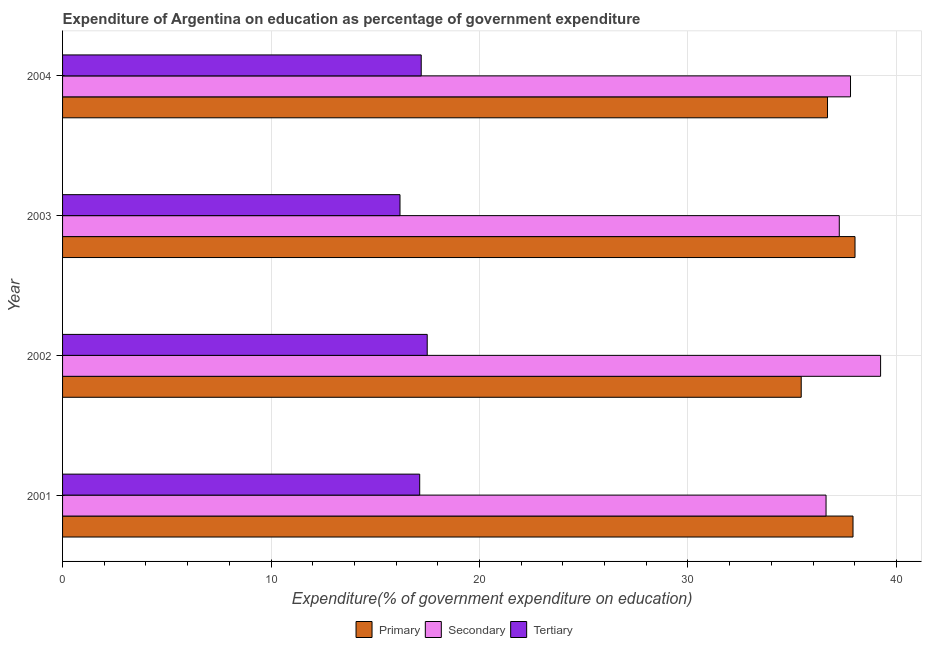How many bars are there on the 4th tick from the top?
Provide a short and direct response. 3. In how many cases, is the number of bars for a given year not equal to the number of legend labels?
Your answer should be compact. 0. What is the expenditure on primary education in 2003?
Make the answer very short. 38.01. Across all years, what is the maximum expenditure on secondary education?
Provide a succinct answer. 39.24. Across all years, what is the minimum expenditure on secondary education?
Make the answer very short. 36.63. In which year was the expenditure on tertiary education maximum?
Your answer should be compact. 2002. What is the total expenditure on secondary education in the graph?
Your answer should be very brief. 150.93. What is the difference between the expenditure on tertiary education in 2002 and that in 2004?
Provide a succinct answer. 0.29. What is the difference between the expenditure on tertiary education in 2001 and the expenditure on primary education in 2004?
Give a very brief answer. -19.56. What is the average expenditure on tertiary education per year?
Your answer should be very brief. 17. In the year 2003, what is the difference between the expenditure on tertiary education and expenditure on secondary education?
Make the answer very short. -21.07. What is the ratio of the expenditure on primary education in 2001 to that in 2004?
Provide a succinct answer. 1.03. What is the difference between the highest and the second highest expenditure on secondary education?
Offer a very short reply. 1.44. What is the difference between the highest and the lowest expenditure on tertiary education?
Offer a very short reply. 1.31. In how many years, is the expenditure on primary education greater than the average expenditure on primary education taken over all years?
Make the answer very short. 2. What does the 2nd bar from the top in 2004 represents?
Your response must be concise. Secondary. What does the 2nd bar from the bottom in 2001 represents?
Give a very brief answer. Secondary. How many years are there in the graph?
Offer a terse response. 4. Are the values on the major ticks of X-axis written in scientific E-notation?
Provide a short and direct response. No. Does the graph contain grids?
Keep it short and to the point. Yes. Where does the legend appear in the graph?
Provide a short and direct response. Bottom center. How many legend labels are there?
Keep it short and to the point. 3. How are the legend labels stacked?
Provide a short and direct response. Horizontal. What is the title of the graph?
Your answer should be very brief. Expenditure of Argentina on education as percentage of government expenditure. Does "Primary education" appear as one of the legend labels in the graph?
Provide a succinct answer. No. What is the label or title of the X-axis?
Give a very brief answer. Expenditure(% of government expenditure on education). What is the label or title of the Y-axis?
Provide a succinct answer. Year. What is the Expenditure(% of government expenditure on education) in Primary in 2001?
Offer a very short reply. 37.92. What is the Expenditure(% of government expenditure on education) of Secondary in 2001?
Your answer should be very brief. 36.63. What is the Expenditure(% of government expenditure on education) in Tertiary in 2001?
Offer a terse response. 17.13. What is the Expenditure(% of government expenditure on education) in Primary in 2002?
Your answer should be compact. 35.43. What is the Expenditure(% of government expenditure on education) in Secondary in 2002?
Ensure brevity in your answer.  39.24. What is the Expenditure(% of government expenditure on education) in Tertiary in 2002?
Keep it short and to the point. 17.49. What is the Expenditure(% of government expenditure on education) in Primary in 2003?
Ensure brevity in your answer.  38.01. What is the Expenditure(% of government expenditure on education) of Secondary in 2003?
Give a very brief answer. 37.26. What is the Expenditure(% of government expenditure on education) in Tertiary in 2003?
Provide a succinct answer. 16.19. What is the Expenditure(% of government expenditure on education) of Primary in 2004?
Your answer should be very brief. 36.7. What is the Expenditure(% of government expenditure on education) in Secondary in 2004?
Provide a succinct answer. 37.8. What is the Expenditure(% of government expenditure on education) in Tertiary in 2004?
Make the answer very short. 17.2. Across all years, what is the maximum Expenditure(% of government expenditure on education) of Primary?
Give a very brief answer. 38.01. Across all years, what is the maximum Expenditure(% of government expenditure on education) in Secondary?
Offer a very short reply. 39.24. Across all years, what is the maximum Expenditure(% of government expenditure on education) in Tertiary?
Provide a succinct answer. 17.49. Across all years, what is the minimum Expenditure(% of government expenditure on education) of Primary?
Give a very brief answer. 35.43. Across all years, what is the minimum Expenditure(% of government expenditure on education) of Secondary?
Keep it short and to the point. 36.63. Across all years, what is the minimum Expenditure(% of government expenditure on education) in Tertiary?
Provide a succinct answer. 16.19. What is the total Expenditure(% of government expenditure on education) in Primary in the graph?
Offer a very short reply. 148.06. What is the total Expenditure(% of government expenditure on education) of Secondary in the graph?
Offer a terse response. 150.93. What is the total Expenditure(% of government expenditure on education) of Tertiary in the graph?
Your answer should be compact. 68.02. What is the difference between the Expenditure(% of government expenditure on education) in Primary in 2001 and that in 2002?
Provide a succinct answer. 2.48. What is the difference between the Expenditure(% of government expenditure on education) of Secondary in 2001 and that in 2002?
Your answer should be very brief. -2.62. What is the difference between the Expenditure(% of government expenditure on education) in Tertiary in 2001 and that in 2002?
Make the answer very short. -0.36. What is the difference between the Expenditure(% of government expenditure on education) in Primary in 2001 and that in 2003?
Your answer should be compact. -0.1. What is the difference between the Expenditure(% of government expenditure on education) in Secondary in 2001 and that in 2003?
Give a very brief answer. -0.63. What is the difference between the Expenditure(% of government expenditure on education) in Tertiary in 2001 and that in 2003?
Your answer should be compact. 0.94. What is the difference between the Expenditure(% of government expenditure on education) of Primary in 2001 and that in 2004?
Make the answer very short. 1.22. What is the difference between the Expenditure(% of government expenditure on education) of Secondary in 2001 and that in 2004?
Make the answer very short. -1.17. What is the difference between the Expenditure(% of government expenditure on education) of Tertiary in 2001 and that in 2004?
Provide a succinct answer. -0.07. What is the difference between the Expenditure(% of government expenditure on education) in Primary in 2002 and that in 2003?
Your answer should be very brief. -2.58. What is the difference between the Expenditure(% of government expenditure on education) of Secondary in 2002 and that in 2003?
Offer a terse response. 1.98. What is the difference between the Expenditure(% of government expenditure on education) of Tertiary in 2002 and that in 2003?
Give a very brief answer. 1.31. What is the difference between the Expenditure(% of government expenditure on education) of Primary in 2002 and that in 2004?
Give a very brief answer. -1.26. What is the difference between the Expenditure(% of government expenditure on education) in Secondary in 2002 and that in 2004?
Give a very brief answer. 1.44. What is the difference between the Expenditure(% of government expenditure on education) of Tertiary in 2002 and that in 2004?
Offer a terse response. 0.29. What is the difference between the Expenditure(% of government expenditure on education) of Primary in 2003 and that in 2004?
Your answer should be very brief. 1.32. What is the difference between the Expenditure(% of government expenditure on education) in Secondary in 2003 and that in 2004?
Provide a short and direct response. -0.54. What is the difference between the Expenditure(% of government expenditure on education) of Tertiary in 2003 and that in 2004?
Provide a short and direct response. -1.02. What is the difference between the Expenditure(% of government expenditure on education) in Primary in 2001 and the Expenditure(% of government expenditure on education) in Secondary in 2002?
Provide a succinct answer. -1.32. What is the difference between the Expenditure(% of government expenditure on education) in Primary in 2001 and the Expenditure(% of government expenditure on education) in Tertiary in 2002?
Provide a short and direct response. 20.43. What is the difference between the Expenditure(% of government expenditure on education) in Secondary in 2001 and the Expenditure(% of government expenditure on education) in Tertiary in 2002?
Ensure brevity in your answer.  19.13. What is the difference between the Expenditure(% of government expenditure on education) of Primary in 2001 and the Expenditure(% of government expenditure on education) of Secondary in 2003?
Your answer should be compact. 0.66. What is the difference between the Expenditure(% of government expenditure on education) in Primary in 2001 and the Expenditure(% of government expenditure on education) in Tertiary in 2003?
Make the answer very short. 21.73. What is the difference between the Expenditure(% of government expenditure on education) of Secondary in 2001 and the Expenditure(% of government expenditure on education) of Tertiary in 2003?
Provide a short and direct response. 20.44. What is the difference between the Expenditure(% of government expenditure on education) in Primary in 2001 and the Expenditure(% of government expenditure on education) in Secondary in 2004?
Provide a succinct answer. 0.12. What is the difference between the Expenditure(% of government expenditure on education) of Primary in 2001 and the Expenditure(% of government expenditure on education) of Tertiary in 2004?
Ensure brevity in your answer.  20.71. What is the difference between the Expenditure(% of government expenditure on education) in Secondary in 2001 and the Expenditure(% of government expenditure on education) in Tertiary in 2004?
Your answer should be compact. 19.42. What is the difference between the Expenditure(% of government expenditure on education) of Primary in 2002 and the Expenditure(% of government expenditure on education) of Secondary in 2003?
Keep it short and to the point. -1.83. What is the difference between the Expenditure(% of government expenditure on education) of Primary in 2002 and the Expenditure(% of government expenditure on education) of Tertiary in 2003?
Your response must be concise. 19.25. What is the difference between the Expenditure(% of government expenditure on education) in Secondary in 2002 and the Expenditure(% of government expenditure on education) in Tertiary in 2003?
Your answer should be compact. 23.05. What is the difference between the Expenditure(% of government expenditure on education) of Primary in 2002 and the Expenditure(% of government expenditure on education) of Secondary in 2004?
Offer a very short reply. -2.37. What is the difference between the Expenditure(% of government expenditure on education) of Primary in 2002 and the Expenditure(% of government expenditure on education) of Tertiary in 2004?
Your answer should be compact. 18.23. What is the difference between the Expenditure(% of government expenditure on education) in Secondary in 2002 and the Expenditure(% of government expenditure on education) in Tertiary in 2004?
Make the answer very short. 22.04. What is the difference between the Expenditure(% of government expenditure on education) in Primary in 2003 and the Expenditure(% of government expenditure on education) in Secondary in 2004?
Keep it short and to the point. 0.22. What is the difference between the Expenditure(% of government expenditure on education) of Primary in 2003 and the Expenditure(% of government expenditure on education) of Tertiary in 2004?
Give a very brief answer. 20.81. What is the difference between the Expenditure(% of government expenditure on education) in Secondary in 2003 and the Expenditure(% of government expenditure on education) in Tertiary in 2004?
Ensure brevity in your answer.  20.06. What is the average Expenditure(% of government expenditure on education) of Primary per year?
Provide a succinct answer. 37.02. What is the average Expenditure(% of government expenditure on education) of Secondary per year?
Make the answer very short. 37.73. What is the average Expenditure(% of government expenditure on education) in Tertiary per year?
Your answer should be compact. 17. In the year 2001, what is the difference between the Expenditure(% of government expenditure on education) in Primary and Expenditure(% of government expenditure on education) in Secondary?
Offer a very short reply. 1.29. In the year 2001, what is the difference between the Expenditure(% of government expenditure on education) of Primary and Expenditure(% of government expenditure on education) of Tertiary?
Make the answer very short. 20.79. In the year 2001, what is the difference between the Expenditure(% of government expenditure on education) in Secondary and Expenditure(% of government expenditure on education) in Tertiary?
Offer a terse response. 19.49. In the year 2002, what is the difference between the Expenditure(% of government expenditure on education) of Primary and Expenditure(% of government expenditure on education) of Secondary?
Provide a short and direct response. -3.81. In the year 2002, what is the difference between the Expenditure(% of government expenditure on education) in Primary and Expenditure(% of government expenditure on education) in Tertiary?
Your response must be concise. 17.94. In the year 2002, what is the difference between the Expenditure(% of government expenditure on education) of Secondary and Expenditure(% of government expenditure on education) of Tertiary?
Ensure brevity in your answer.  21.75. In the year 2003, what is the difference between the Expenditure(% of government expenditure on education) of Primary and Expenditure(% of government expenditure on education) of Secondary?
Keep it short and to the point. 0.75. In the year 2003, what is the difference between the Expenditure(% of government expenditure on education) in Primary and Expenditure(% of government expenditure on education) in Tertiary?
Your response must be concise. 21.83. In the year 2003, what is the difference between the Expenditure(% of government expenditure on education) in Secondary and Expenditure(% of government expenditure on education) in Tertiary?
Provide a short and direct response. 21.07. In the year 2004, what is the difference between the Expenditure(% of government expenditure on education) of Primary and Expenditure(% of government expenditure on education) of Secondary?
Your answer should be very brief. -1.1. In the year 2004, what is the difference between the Expenditure(% of government expenditure on education) of Primary and Expenditure(% of government expenditure on education) of Tertiary?
Offer a very short reply. 19.49. In the year 2004, what is the difference between the Expenditure(% of government expenditure on education) in Secondary and Expenditure(% of government expenditure on education) in Tertiary?
Keep it short and to the point. 20.59. What is the ratio of the Expenditure(% of government expenditure on education) in Primary in 2001 to that in 2002?
Provide a succinct answer. 1.07. What is the ratio of the Expenditure(% of government expenditure on education) in Secondary in 2001 to that in 2002?
Your answer should be very brief. 0.93. What is the ratio of the Expenditure(% of government expenditure on education) of Tertiary in 2001 to that in 2002?
Offer a very short reply. 0.98. What is the ratio of the Expenditure(% of government expenditure on education) in Secondary in 2001 to that in 2003?
Ensure brevity in your answer.  0.98. What is the ratio of the Expenditure(% of government expenditure on education) in Tertiary in 2001 to that in 2003?
Keep it short and to the point. 1.06. What is the ratio of the Expenditure(% of government expenditure on education) of Primary in 2001 to that in 2004?
Make the answer very short. 1.03. What is the ratio of the Expenditure(% of government expenditure on education) in Secondary in 2001 to that in 2004?
Ensure brevity in your answer.  0.97. What is the ratio of the Expenditure(% of government expenditure on education) in Tertiary in 2001 to that in 2004?
Your response must be concise. 1. What is the ratio of the Expenditure(% of government expenditure on education) in Primary in 2002 to that in 2003?
Make the answer very short. 0.93. What is the ratio of the Expenditure(% of government expenditure on education) of Secondary in 2002 to that in 2003?
Provide a short and direct response. 1.05. What is the ratio of the Expenditure(% of government expenditure on education) in Tertiary in 2002 to that in 2003?
Your response must be concise. 1.08. What is the ratio of the Expenditure(% of government expenditure on education) of Primary in 2002 to that in 2004?
Offer a terse response. 0.97. What is the ratio of the Expenditure(% of government expenditure on education) in Secondary in 2002 to that in 2004?
Your answer should be compact. 1.04. What is the ratio of the Expenditure(% of government expenditure on education) of Tertiary in 2002 to that in 2004?
Your response must be concise. 1.02. What is the ratio of the Expenditure(% of government expenditure on education) in Primary in 2003 to that in 2004?
Your response must be concise. 1.04. What is the ratio of the Expenditure(% of government expenditure on education) of Secondary in 2003 to that in 2004?
Provide a short and direct response. 0.99. What is the ratio of the Expenditure(% of government expenditure on education) in Tertiary in 2003 to that in 2004?
Your response must be concise. 0.94. What is the difference between the highest and the second highest Expenditure(% of government expenditure on education) in Primary?
Make the answer very short. 0.1. What is the difference between the highest and the second highest Expenditure(% of government expenditure on education) in Secondary?
Your answer should be compact. 1.44. What is the difference between the highest and the second highest Expenditure(% of government expenditure on education) in Tertiary?
Keep it short and to the point. 0.29. What is the difference between the highest and the lowest Expenditure(% of government expenditure on education) in Primary?
Make the answer very short. 2.58. What is the difference between the highest and the lowest Expenditure(% of government expenditure on education) in Secondary?
Make the answer very short. 2.62. What is the difference between the highest and the lowest Expenditure(% of government expenditure on education) in Tertiary?
Offer a terse response. 1.31. 